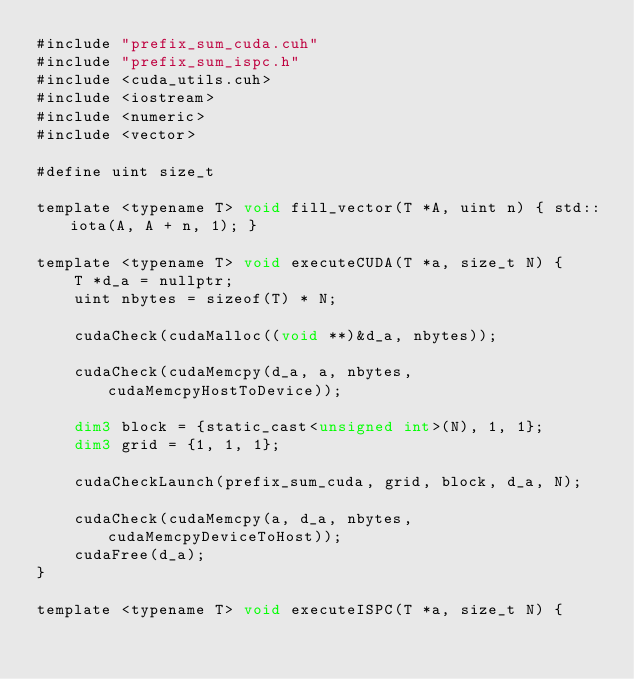Convert code to text. <code><loc_0><loc_0><loc_500><loc_500><_Cuda_>#include "prefix_sum_cuda.cuh"
#include "prefix_sum_ispc.h"
#include <cuda_utils.cuh>
#include <iostream>
#include <numeric>
#include <vector>

#define uint size_t

template <typename T> void fill_vector(T *A, uint n) { std::iota(A, A + n, 1); }

template <typename T> void executeCUDA(T *a, size_t N) {
    T *d_a = nullptr;
    uint nbytes = sizeof(T) * N;

    cudaCheck(cudaMalloc((void **)&d_a, nbytes));

    cudaCheck(cudaMemcpy(d_a, a, nbytes, cudaMemcpyHostToDevice));

    dim3 block = {static_cast<unsigned int>(N), 1, 1};
    dim3 grid = {1, 1, 1};

    cudaCheckLaunch(prefix_sum_cuda, grid, block, d_a, N);

    cudaCheck(cudaMemcpy(a, d_a, nbytes, cudaMemcpyDeviceToHost));
    cudaFree(d_a);
}

template <typename T> void executeISPC(T *a, size_t N) {</code> 